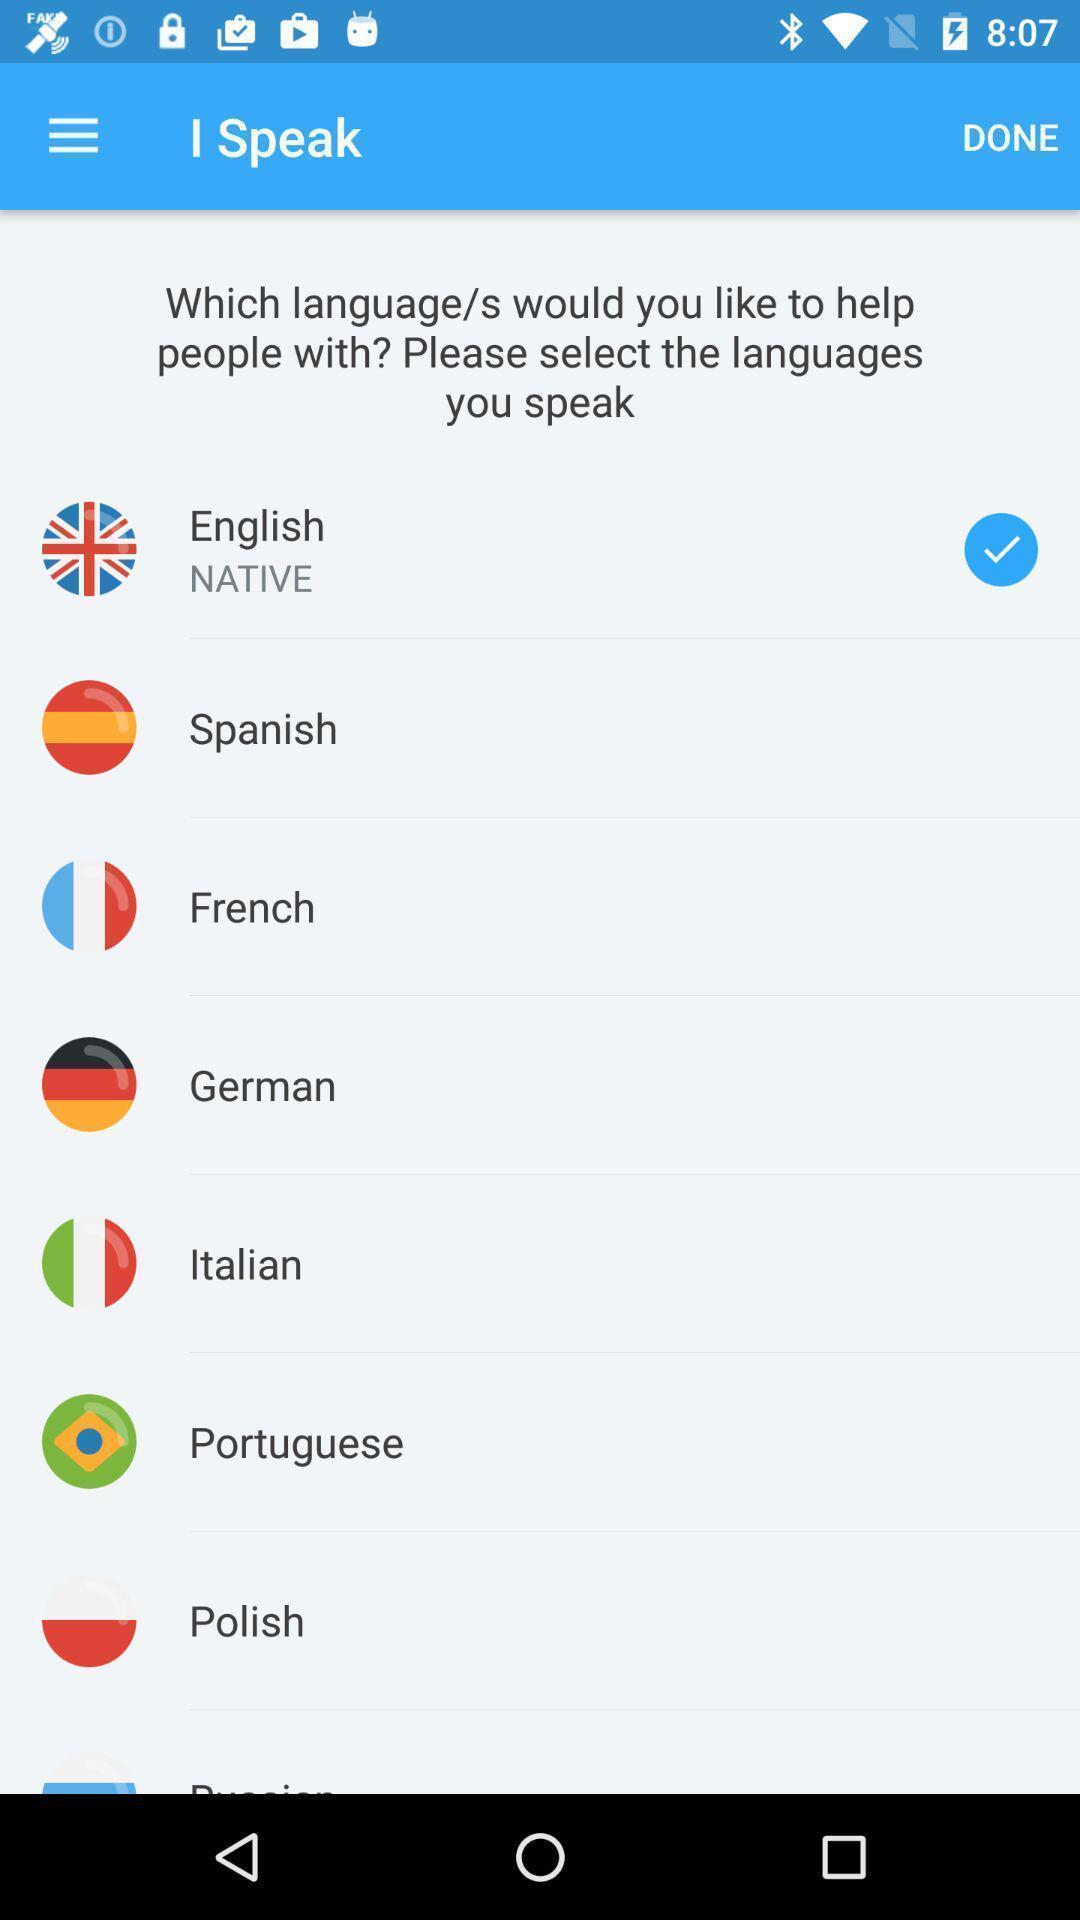Tell me about the visual elements in this screen capture. Screen displaying the list of languages. 